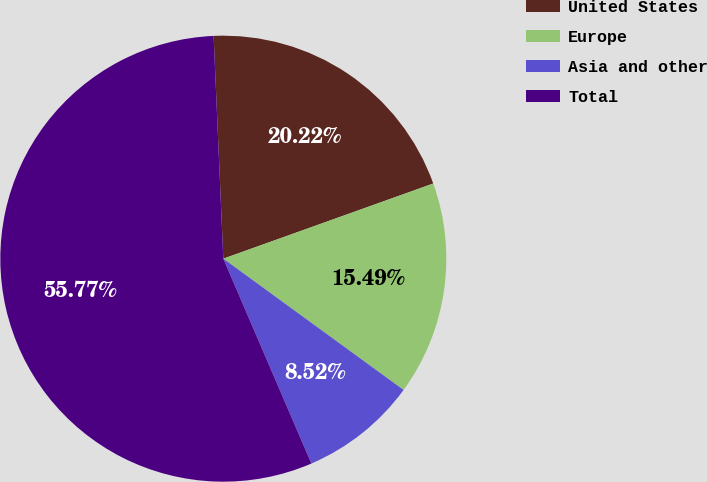<chart> <loc_0><loc_0><loc_500><loc_500><pie_chart><fcel>United States<fcel>Europe<fcel>Asia and other<fcel>Total<nl><fcel>20.22%<fcel>15.49%<fcel>8.52%<fcel>55.77%<nl></chart> 